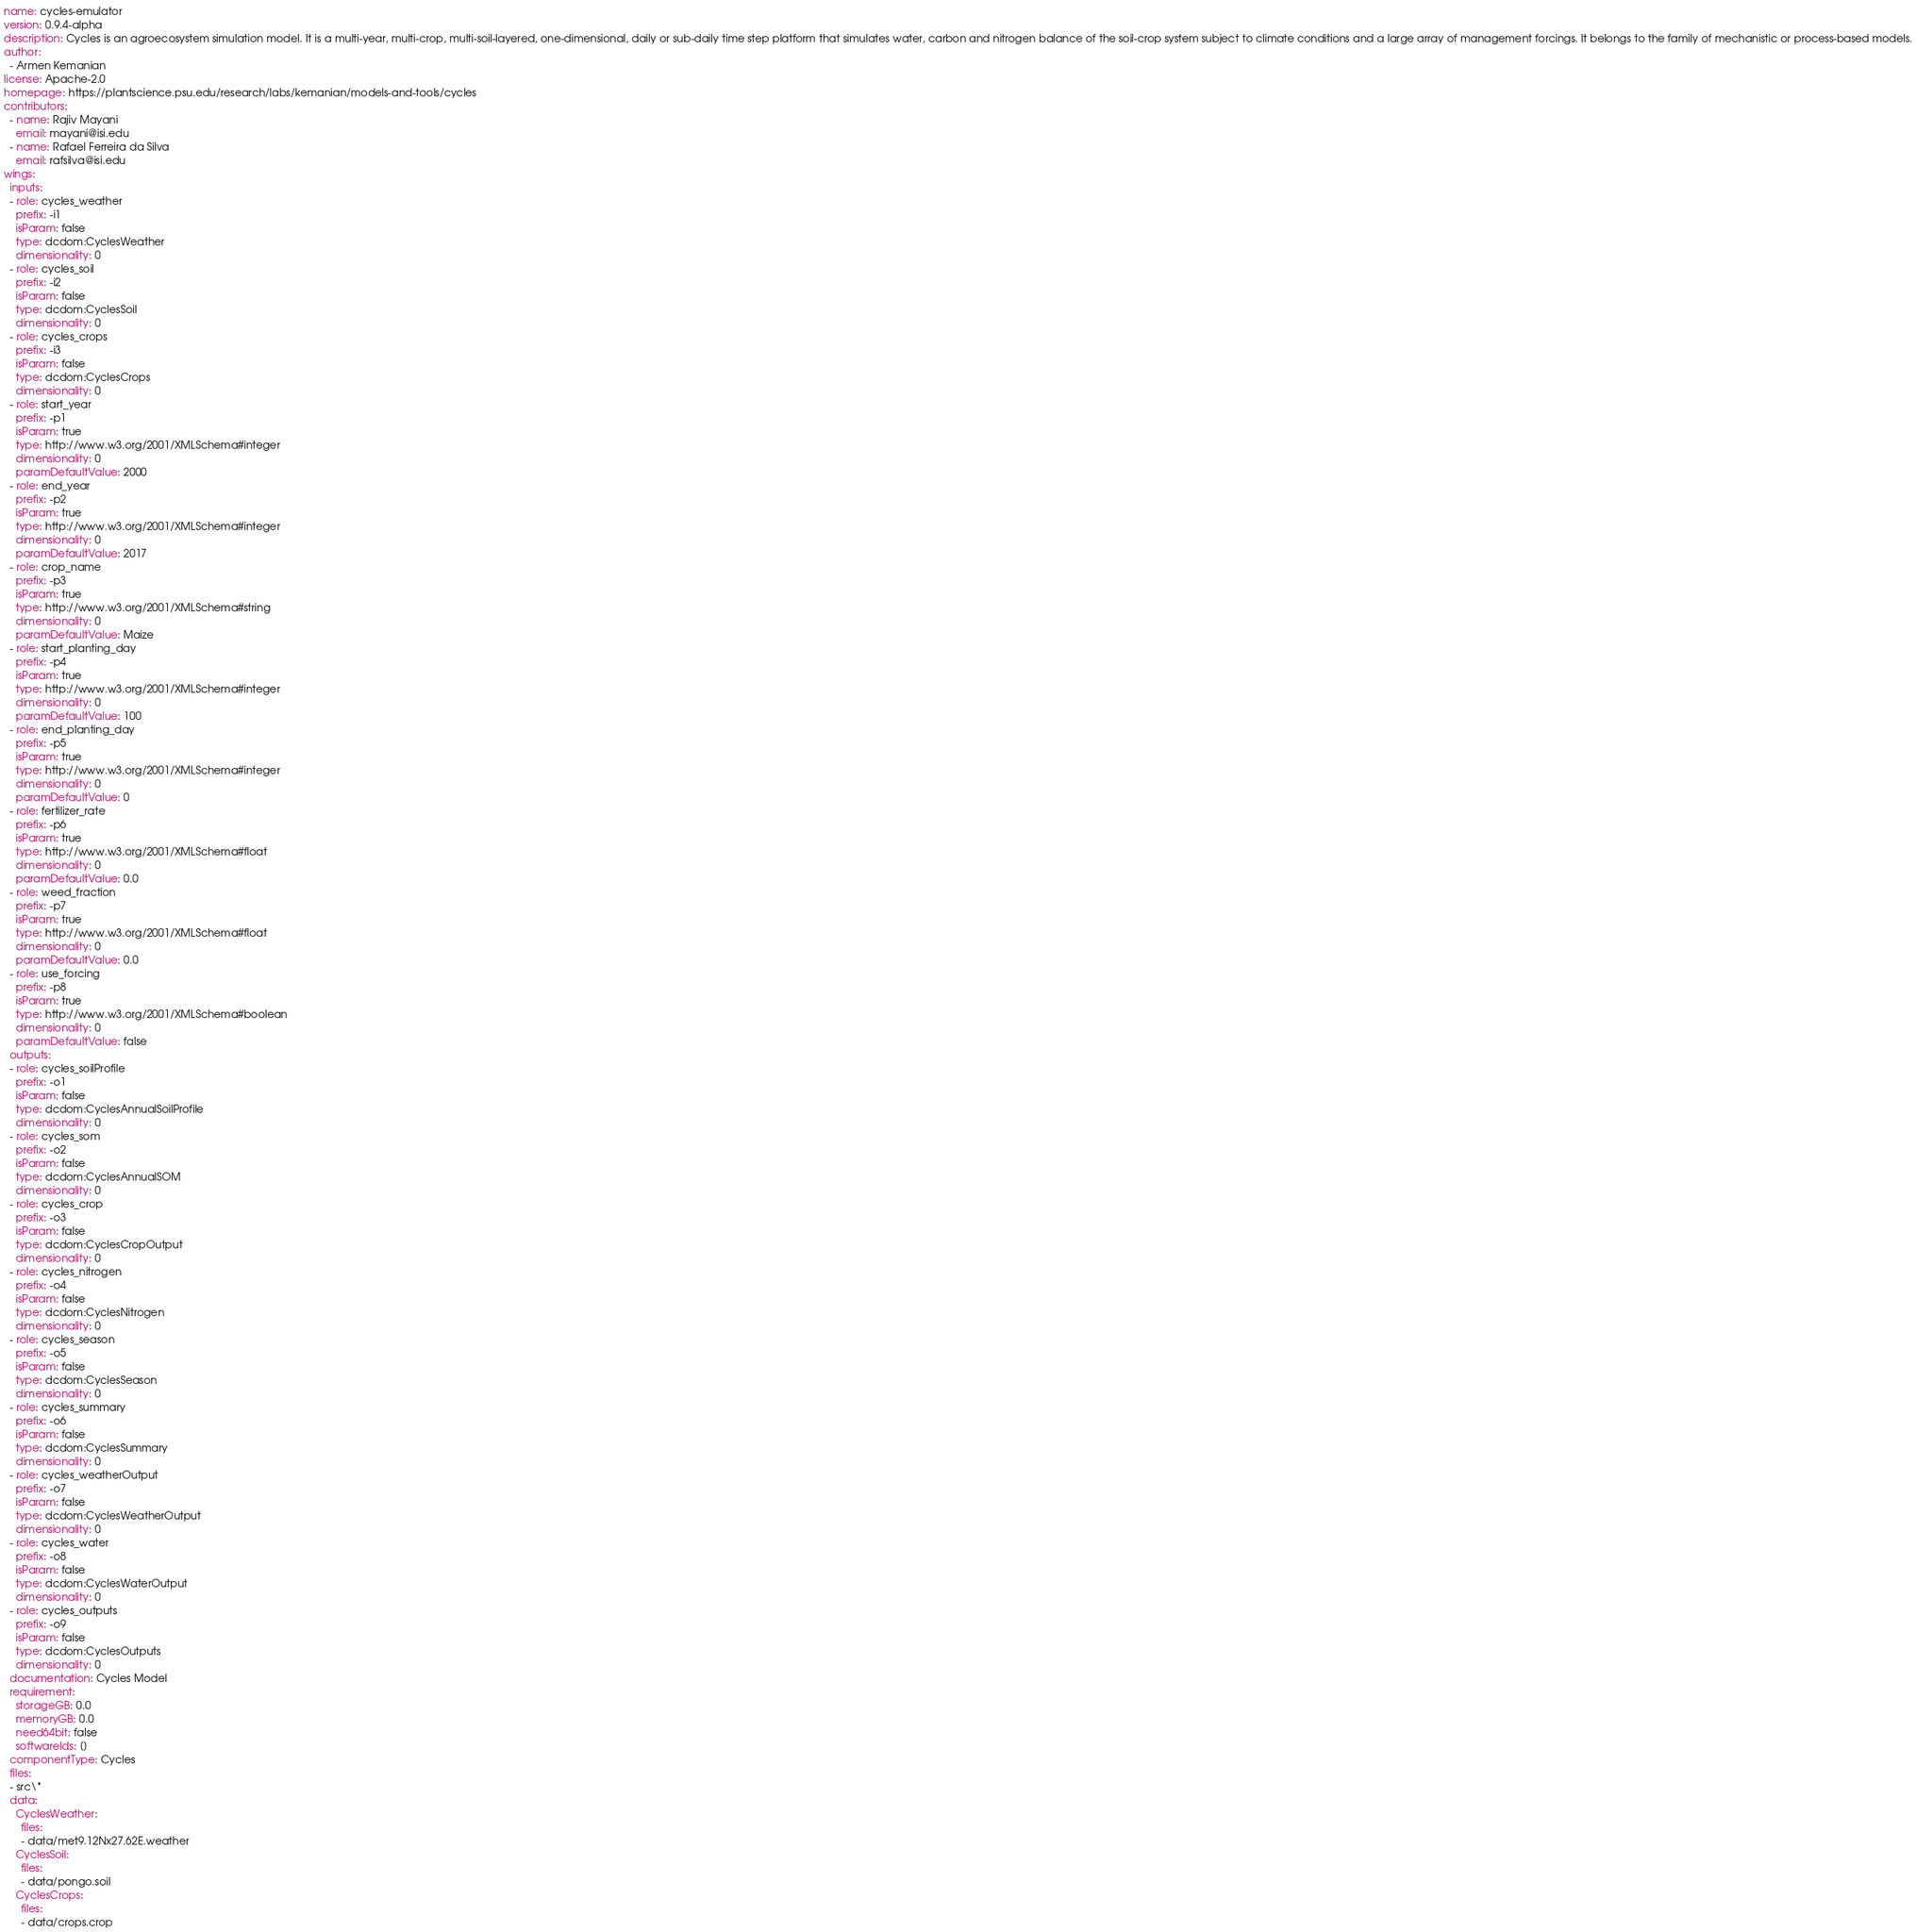<code> <loc_0><loc_0><loc_500><loc_500><_YAML_>name: cycles-emulator
version: 0.9.4-alpha
description: Cycles is an agroecosystem simulation model. It is a multi-year, multi-crop, multi-soil-layered, one-dimensional, daily or sub-daily time step platform that simulates water, carbon and nitrogen balance of the soil-crop system subject to climate conditions and a large array of management forcings. It belongs to the family of mechanistic or process-based models.
author:
  - Armen Kemanian
license: Apache-2.0
homepage: https://plantscience.psu.edu/research/labs/kemanian/models-and-tools/cycles
contributors:
  - name: Rajiv Mayani
    email: mayani@isi.edu
  - name: Rafael Ferreira da Silva
    email: rafsilva@isi.edu
wings:
  inputs:
  - role: cycles_weather
    prefix: -i1
    isParam: false
    type: dcdom:CyclesWeather
    dimensionality: 0
  - role: cycles_soil
    prefix: -i2
    isParam: false
    type: dcdom:CyclesSoil
    dimensionality: 0
  - role: cycles_crops
    prefix: -i3
    isParam: false
    type: dcdom:CyclesCrops
    dimensionality: 0
  - role: start_year
    prefix: -p1
    isParam: true
    type: http://www.w3.org/2001/XMLSchema#integer
    dimensionality: 0
    paramDefaultValue: 2000
  - role: end_year
    prefix: -p2
    isParam: true
    type: http://www.w3.org/2001/XMLSchema#integer
    dimensionality: 0
    paramDefaultValue: 2017
  - role: crop_name
    prefix: -p3
    isParam: true
    type: http://www.w3.org/2001/XMLSchema#string
    dimensionality: 0
    paramDefaultValue: Maize
  - role: start_planting_day
    prefix: -p4
    isParam: true
    type: http://www.w3.org/2001/XMLSchema#integer
    dimensionality: 0
    paramDefaultValue: 100
  - role: end_planting_day
    prefix: -p5
    isParam: true
    type: http://www.w3.org/2001/XMLSchema#integer
    dimensionality: 0
    paramDefaultValue: 0
  - role: fertilizer_rate
    prefix: -p6
    isParam: true
    type: http://www.w3.org/2001/XMLSchema#float
    dimensionality: 0
    paramDefaultValue: 0.0
  - role: weed_fraction
    prefix: -p7
    isParam: true
    type: http://www.w3.org/2001/XMLSchema#float
    dimensionality: 0
    paramDefaultValue: 0.0
  - role: use_forcing
    prefix: -p8
    isParam: true
    type: http://www.w3.org/2001/XMLSchema#boolean
    dimensionality: 0
    paramDefaultValue: false
  outputs:
  - role: cycles_soilProfile
    prefix: -o1
    isParam: false
    type: dcdom:CyclesAnnualSoilProfile
    dimensionality: 0
  - role: cycles_som
    prefix: -o2
    isParam: false
    type: dcdom:CyclesAnnualSOM
    dimensionality: 0
  - role: cycles_crop
    prefix: -o3
    isParam: false
    type: dcdom:CyclesCropOutput
    dimensionality: 0
  - role: cycles_nitrogen
    prefix: -o4
    isParam: false
    type: dcdom:CyclesNitrogen
    dimensionality: 0
  - role: cycles_season
    prefix: -o5
    isParam: false
    type: dcdom:CyclesSeason
    dimensionality: 0
  - role: cycles_summary
    prefix: -o6
    isParam: false
    type: dcdom:CyclesSummary
    dimensionality: 0
  - role: cycles_weatherOutput
    prefix: -o7
    isParam: false
    type: dcdom:CyclesWeatherOutput
    dimensionality: 0
  - role: cycles_water
    prefix: -o8
    isParam: false
    type: dcdom:CyclesWaterOutput
    dimensionality: 0
  - role: cycles_outputs
    prefix: -o9
    isParam: false
    type: dcdom:CyclesOutputs
    dimensionality: 0
  documentation: Cycles Model
  requirement:
    storageGB: 0.0
    memoryGB: 0.0
    need64bit: false
    softwareIds: []
  componentType: Cycles
  files:
  - src\*
  data:
    CyclesWeather:
      files:
      - data/met9.12Nx27.62E.weather
    CyclesSoil:
      files:
      - data/pongo.soil
    CyclesCrops:
      files:
      - data/crops.crop
</code> 